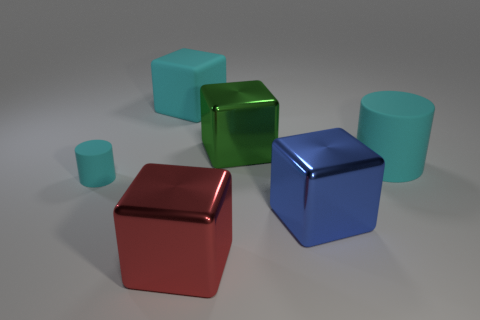Are any blue cylinders visible?
Your response must be concise. No. Is there anything else that is the same color as the tiny object?
Keep it short and to the point. Yes. There is a large blue thing that is the same material as the large green block; what is its shape?
Your answer should be very brief. Cube. The large object left of the large red cube to the left of the metallic block behind the tiny cylinder is what color?
Offer a terse response. Cyan. Are there an equal number of things behind the green shiny cube and matte cubes?
Make the answer very short. Yes. Do the matte block and the matte object that is to the right of the big rubber block have the same color?
Provide a short and direct response. Yes. Are there any large cyan cubes left of the cyan cylinder right of the large shiny block on the right side of the large green metal thing?
Make the answer very short. Yes. Is the number of blue shiny blocks to the left of the small cyan matte cylinder less than the number of green metallic things?
Offer a very short reply. Yes. How many other things are there of the same shape as the red shiny object?
Make the answer very short. 3. What number of things are either cyan matte cylinders that are left of the big red shiny cube or matte cylinders left of the large cyan matte block?
Offer a very short reply. 1. 